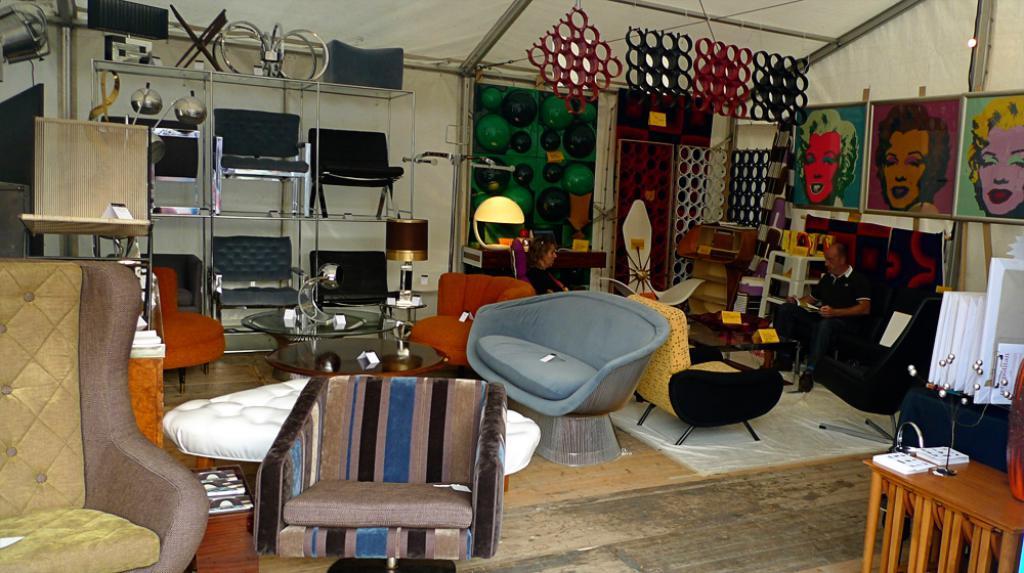How would you summarize this image in a sentence or two? In the middle of the image we can see some chairs and tables and two persons are sitting. Behind them there is wall, on the wall there are some chairs and frames. At the top of the image there is roof. 